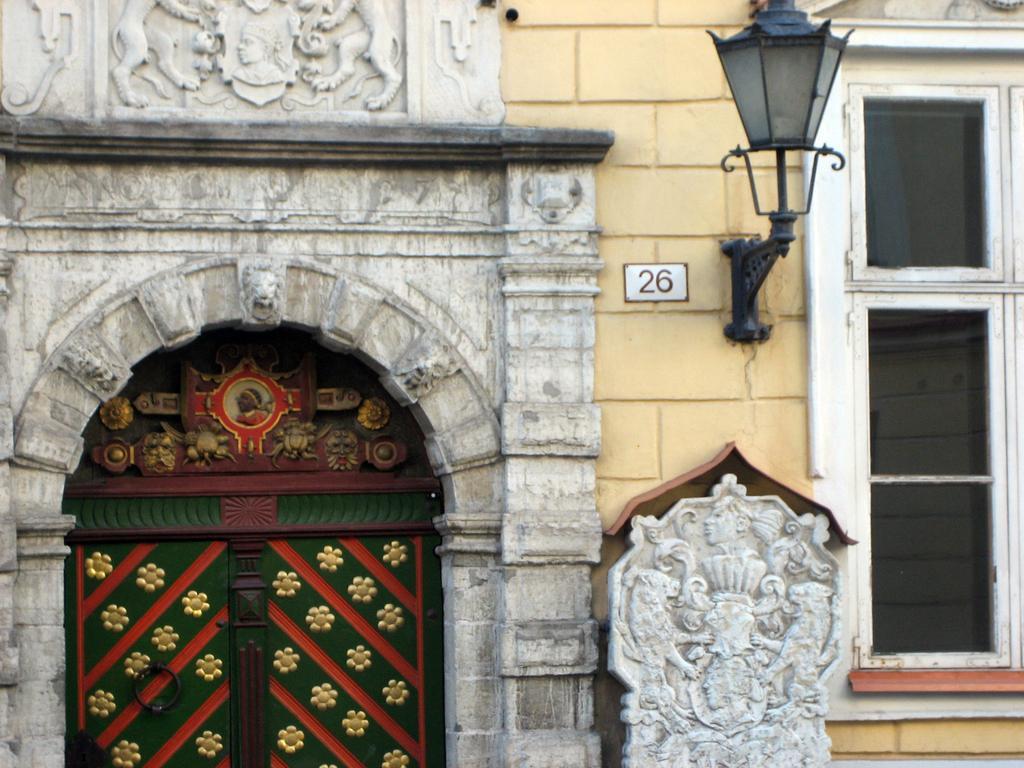Please provide a concise description of this image. This is the picture of a place where we have a window, door, lamp and some sculptures to the wall. 